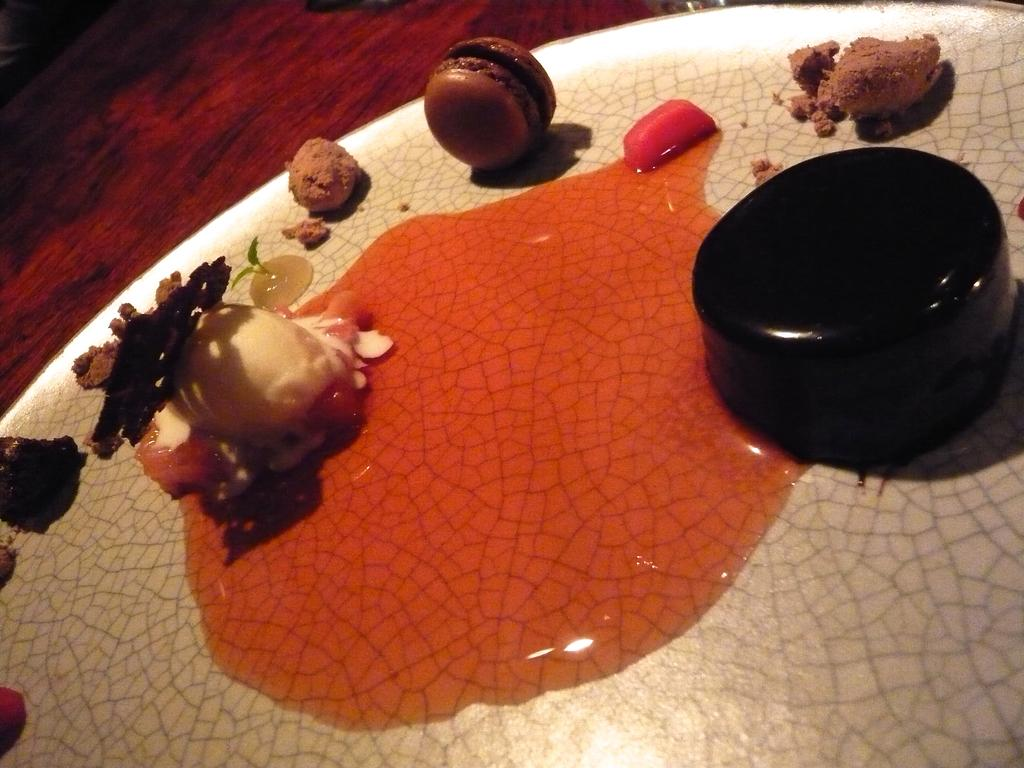What is on the plate that is visible in the image? There is a plate with food items in the image. What is the plate placed on? The plate is placed on a wooden object. What type of badge is the uncle wearing in the image? There is no uncle or badge present in the image; it only features a plate with food items and a wooden object. 